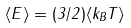<formula> <loc_0><loc_0><loc_500><loc_500>\langle E \rangle = ( 3 / 2 ) \langle k _ { B } T \rangle</formula> 